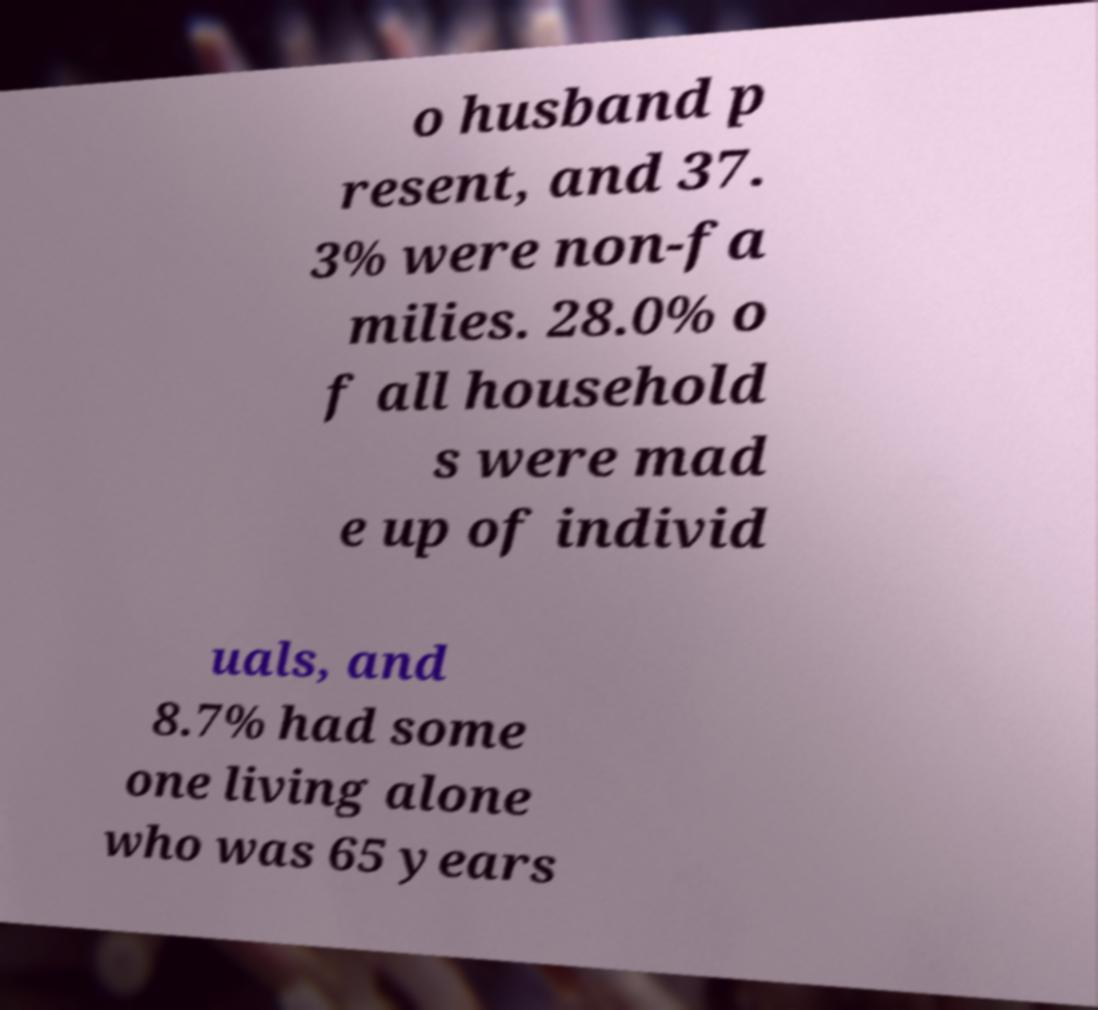Could you assist in decoding the text presented in this image and type it out clearly? o husband p resent, and 37. 3% were non-fa milies. 28.0% o f all household s were mad e up of individ uals, and 8.7% had some one living alone who was 65 years 